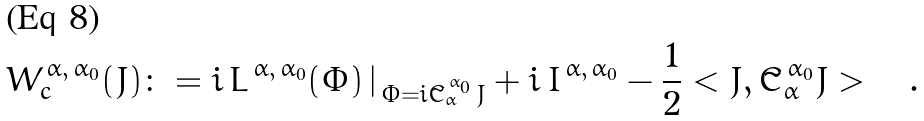<formula> <loc_0><loc_0><loc_500><loc_500>W _ { c } ^ { \, \alpha , \, \alpha _ { 0 } } ( J ) \colon = i \, L ^ { \, \alpha , \, \alpha _ { 0 } } ( \Phi ) \, | _ { \, \Phi = i \tilde { C } _ { \alpha } ^ { \, \alpha _ { 0 } } \, J } + i \, I ^ { \, \alpha , \, \alpha _ { 0 } } - \frac { 1 } { 2 } < J , \tilde { C } _ { \alpha } ^ { \, \alpha _ { 0 } } J > \quad .</formula> 